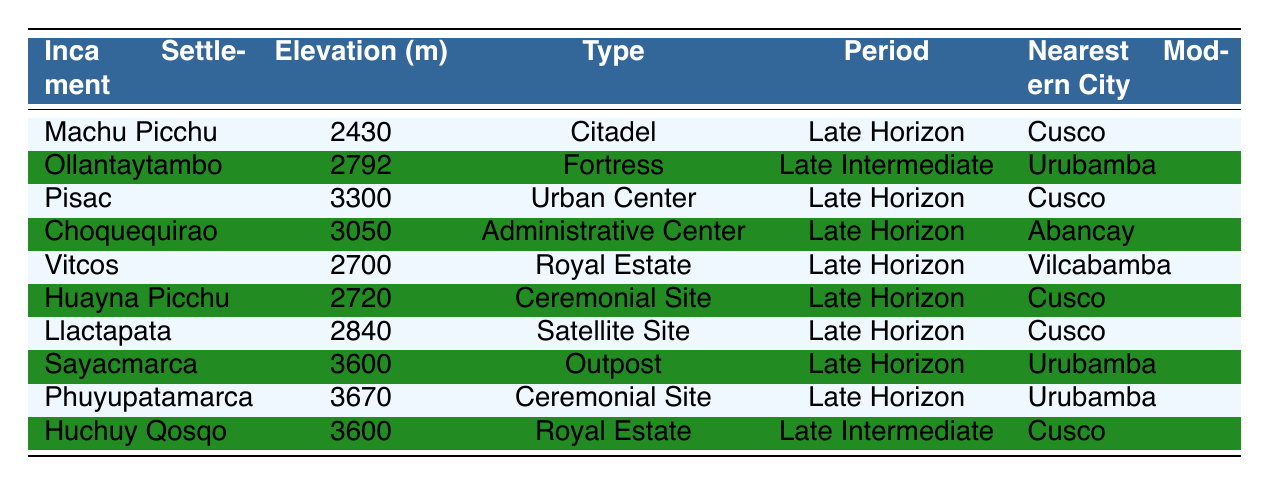What is the elevation of Machu Picchu? The table lists Machu Picchu with an elevation of 2430 meters.
Answer: 2430 meters Which Inca settlement is classified as a fortress? The table shows that Ollantaytambo is identified as a fortress.
Answer: Ollantaytambo How many settlements are at an elevation above 3000 meters? The relevant settlements are Pisac (3300), Choquequirao (3050), Sayacmarca (3600), Phuyupatamarca (3670), and Huchuy Qosqo (3600), totaling five settlements above 3000 meters.
Answer: 5 What is the average elevation of all listed Inca settlements? To find the average elevation, we sum all the elevations: 2430 + 2792 + 3300 + 3050 + 2700 + 2720 + 2840 + 3600 + 3670 + 3600 = 30562 meters. We then divide by the number of settlements (10), yielding an average of 3056.2 meters.
Answer: 3056.2 meters Is there an Inca settlement located in Vilcabamba? The table indicates that Vitcos is a royal estate located in Vilcabamba. Therefore, the statement is true.
Answer: Yes Which settlement has the highest elevation, and what is that elevation? By reviewing the table, we see that Sayacmarca has the highest elevation at 3600 meters, and it is confirmed by checking all the other listed elevations.
Answer: Sayacmarca, 3600 meters Are any of the modern cities listed closer to coastal areas? The table does not list any settlements or modern cities that would suggest proximity to coastal areas; all mentioned cities are inland in the Andes.
Answer: No How many settlements are classified under the 'Late Horizon' period, and what is their average elevation? The 'Late Horizon' settlements are Machu Picchu, Pisac, Choquequirao, Vitcos, Huayna Picchu, Llactapata, Sayacmarca, and Phuyupatamarca, totaling eight settlements. The sum of their elevations is 2430 + 3300 + 3050 + 2700 + 2720 + 2840 + 3600 + 3670 = 22960 meters. The average elevation is 22960/8 = 2870 meters.
Answer: 8, 2870 meters Which Inca settlement nearest to Cusco is an urban center? The table indicates that Pisac is the urban center nearest to Cusco.
Answer: Pisac 